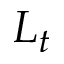Convert formula to latex. <formula><loc_0><loc_0><loc_500><loc_500>L _ { t }</formula> 